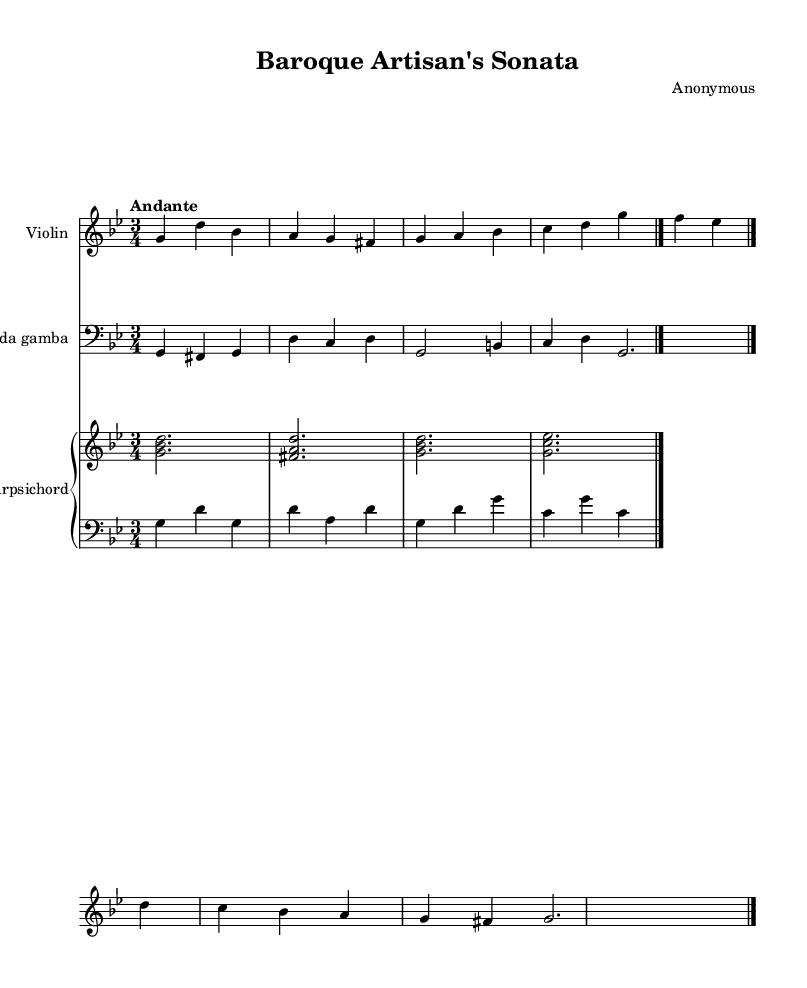What is the key signature of this music? The key signature is G minor, which has two flats (B♭ and E♭). This can be determined by looking at the key signature indicated at the beginning of the music.
Answer: G minor What is the time signature of this music? The time signature is 3/4, which is indicated at the beginning of the score. This means there are three beats in each measure with the quarter note getting one beat.
Answer: 3/4 What is the tempo marking of this piece? The tempo marking is "Andante," which is written above the staff. Andante indicates a moderately slow tempo, typically around 76-108 beats per minute.
Answer: Andante Which instruments are included in the ensemble? The instruments included are Violin, Viola da Gamba, and Harpsichord. These instruments can be identified by the instrument names written at the beginning of each staff.
Answer: Violin, Viola da Gamba, Harpsichord How many measures does the violin part have? The violin part has four measures. By counting the groups of notes separated by bar lines in the violin staff, you can determine the number of measures.
Answer: 4 What type of musical structure does this piece represent? This piece represents a Baroque chamber music structure typical of small ensembles, consisting of a dialogue between the instruments. This is characteristic of the Baroque period where performers would engage in intricate interplay.
Answer: Chamber music What harmonization technique is used between the viola da gamba and the harpsichord? The harmonization technique used is a combination of melody and accompaniment. The viola da gamba plays a melodic line while the harpsichord provides chordal support, with distinct voices in the right and left staffs.
Answer: Melody and accompaniment 